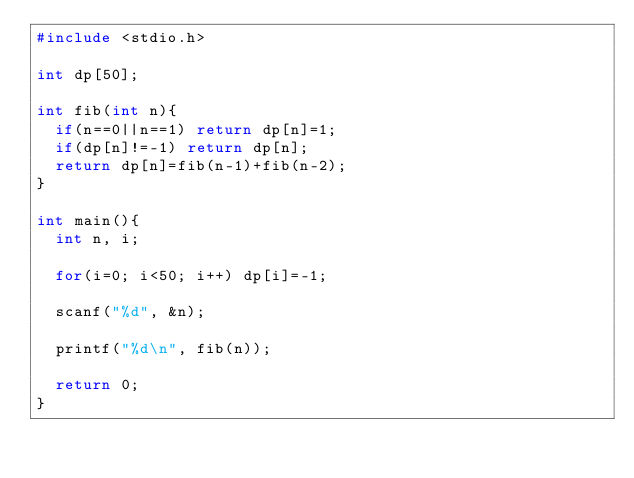Convert code to text. <code><loc_0><loc_0><loc_500><loc_500><_C_>#include <stdio.h>

int dp[50];

int fib(int n){
  if(n==0||n==1) return dp[n]=1;
  if(dp[n]!=-1) return dp[n];
  return dp[n]=fib(n-1)+fib(n-2);
}

int main(){
  int n, i;

  for(i=0; i<50; i++) dp[i]=-1;

  scanf("%d", &n);

  printf("%d\n", fib(n));
  
  return 0;
}

</code> 